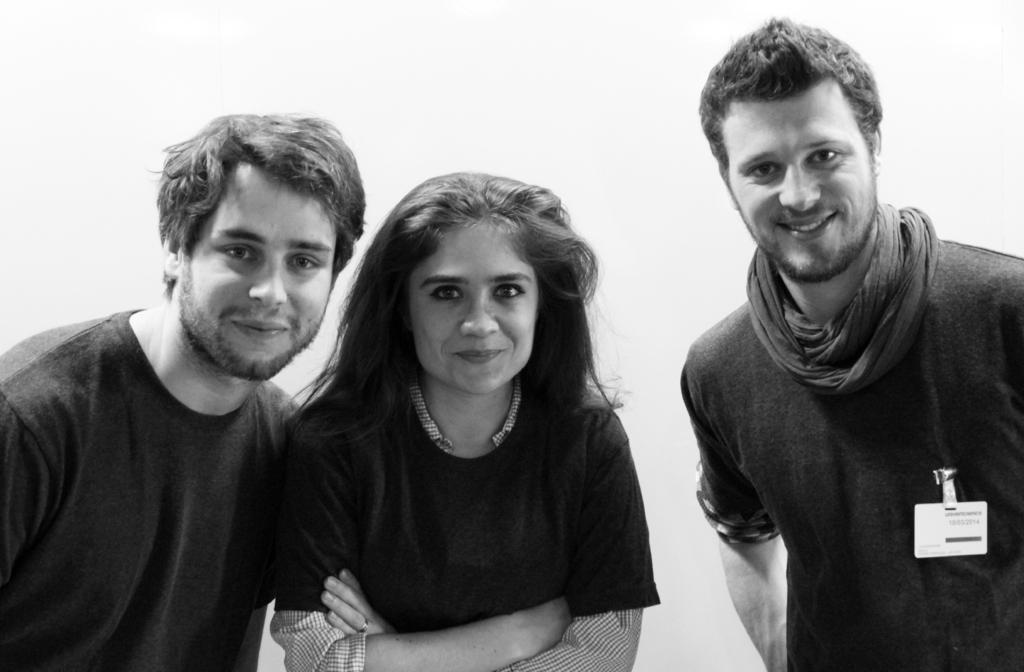Describe this image in one or two sentences. In this picture we can see two men and a woman, they are smiling, and the right side person wore a badge. 